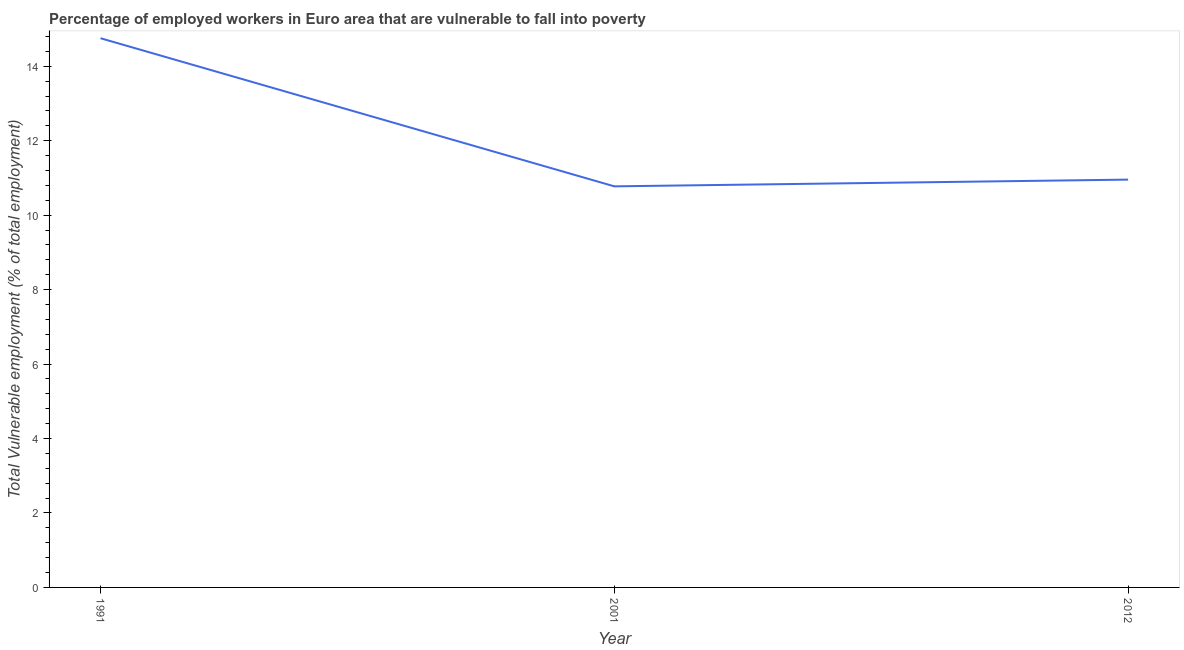What is the total vulnerable employment in 2012?
Ensure brevity in your answer.  10.95. Across all years, what is the maximum total vulnerable employment?
Provide a short and direct response. 14.75. Across all years, what is the minimum total vulnerable employment?
Offer a terse response. 10.77. In which year was the total vulnerable employment maximum?
Make the answer very short. 1991. In which year was the total vulnerable employment minimum?
Your answer should be very brief. 2001. What is the sum of the total vulnerable employment?
Your response must be concise. 36.48. What is the difference between the total vulnerable employment in 1991 and 2001?
Give a very brief answer. 3.98. What is the average total vulnerable employment per year?
Offer a terse response. 12.16. What is the median total vulnerable employment?
Give a very brief answer. 10.95. In how many years, is the total vulnerable employment greater than 2 %?
Provide a succinct answer. 3. What is the ratio of the total vulnerable employment in 1991 to that in 2001?
Your response must be concise. 1.37. What is the difference between the highest and the second highest total vulnerable employment?
Ensure brevity in your answer.  3.8. What is the difference between the highest and the lowest total vulnerable employment?
Your answer should be compact. 3.98. In how many years, is the total vulnerable employment greater than the average total vulnerable employment taken over all years?
Your answer should be very brief. 1. Does the total vulnerable employment monotonically increase over the years?
Your response must be concise. No. How many lines are there?
Ensure brevity in your answer.  1. What is the difference between two consecutive major ticks on the Y-axis?
Your answer should be compact. 2. Are the values on the major ticks of Y-axis written in scientific E-notation?
Provide a short and direct response. No. Does the graph contain grids?
Your answer should be very brief. No. What is the title of the graph?
Your response must be concise. Percentage of employed workers in Euro area that are vulnerable to fall into poverty. What is the label or title of the Y-axis?
Your answer should be very brief. Total Vulnerable employment (% of total employment). What is the Total Vulnerable employment (% of total employment) of 1991?
Ensure brevity in your answer.  14.75. What is the Total Vulnerable employment (% of total employment) of 2001?
Your response must be concise. 10.77. What is the Total Vulnerable employment (% of total employment) of 2012?
Offer a terse response. 10.95. What is the difference between the Total Vulnerable employment (% of total employment) in 1991 and 2001?
Make the answer very short. 3.98. What is the difference between the Total Vulnerable employment (% of total employment) in 1991 and 2012?
Make the answer very short. 3.8. What is the difference between the Total Vulnerable employment (% of total employment) in 2001 and 2012?
Ensure brevity in your answer.  -0.18. What is the ratio of the Total Vulnerable employment (% of total employment) in 1991 to that in 2001?
Provide a short and direct response. 1.37. What is the ratio of the Total Vulnerable employment (% of total employment) in 1991 to that in 2012?
Offer a terse response. 1.35. What is the ratio of the Total Vulnerable employment (% of total employment) in 2001 to that in 2012?
Make the answer very short. 0.98. 